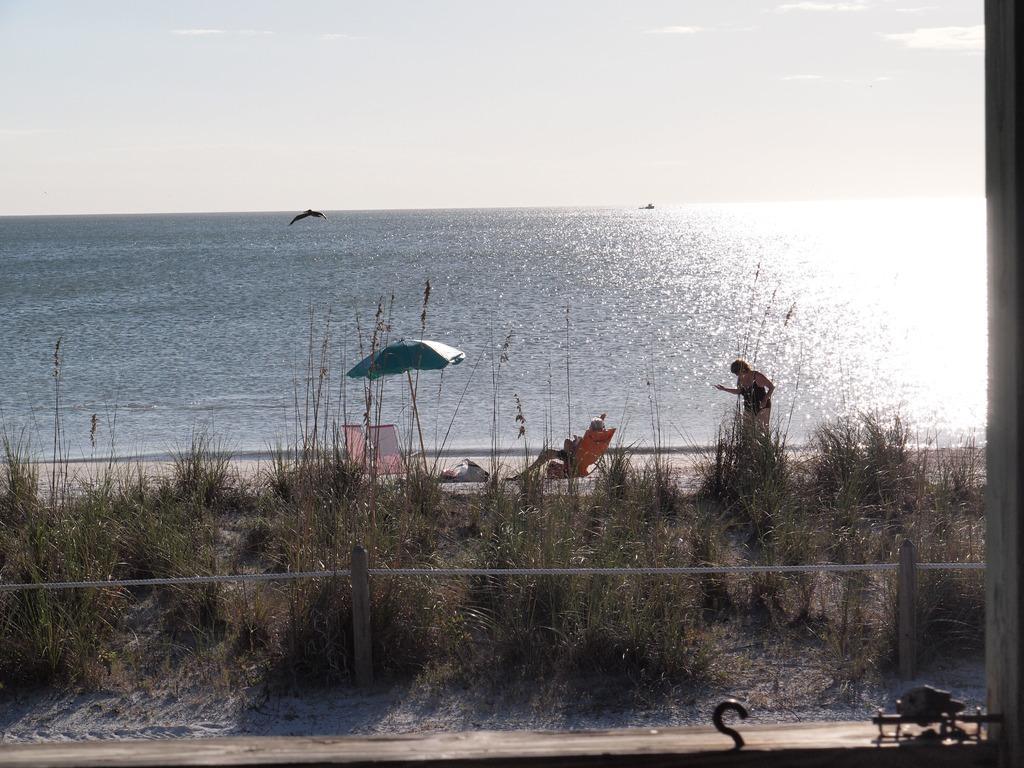Can you describe this image briefly? In this image, there are a few people. We can see the ground with some objects and an umbrella. We can also see some grass and plants. We can see some water and a bird. We can see the sky with clouds. We can also see some objects at the bottom. We can also see an object on the right. We can also see some poles with ropes. 